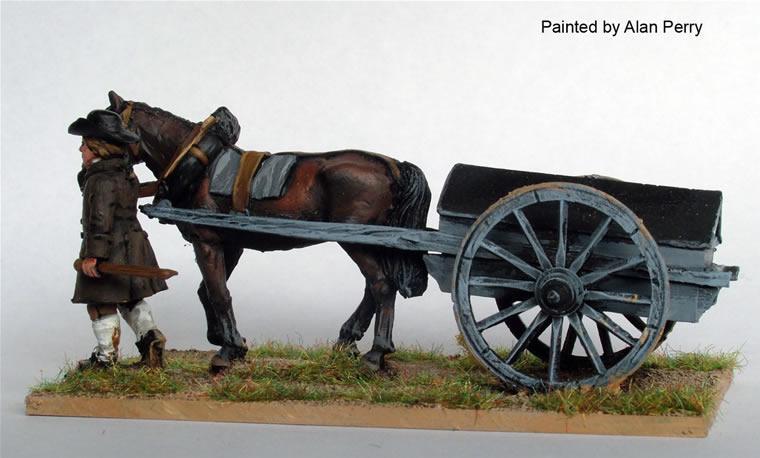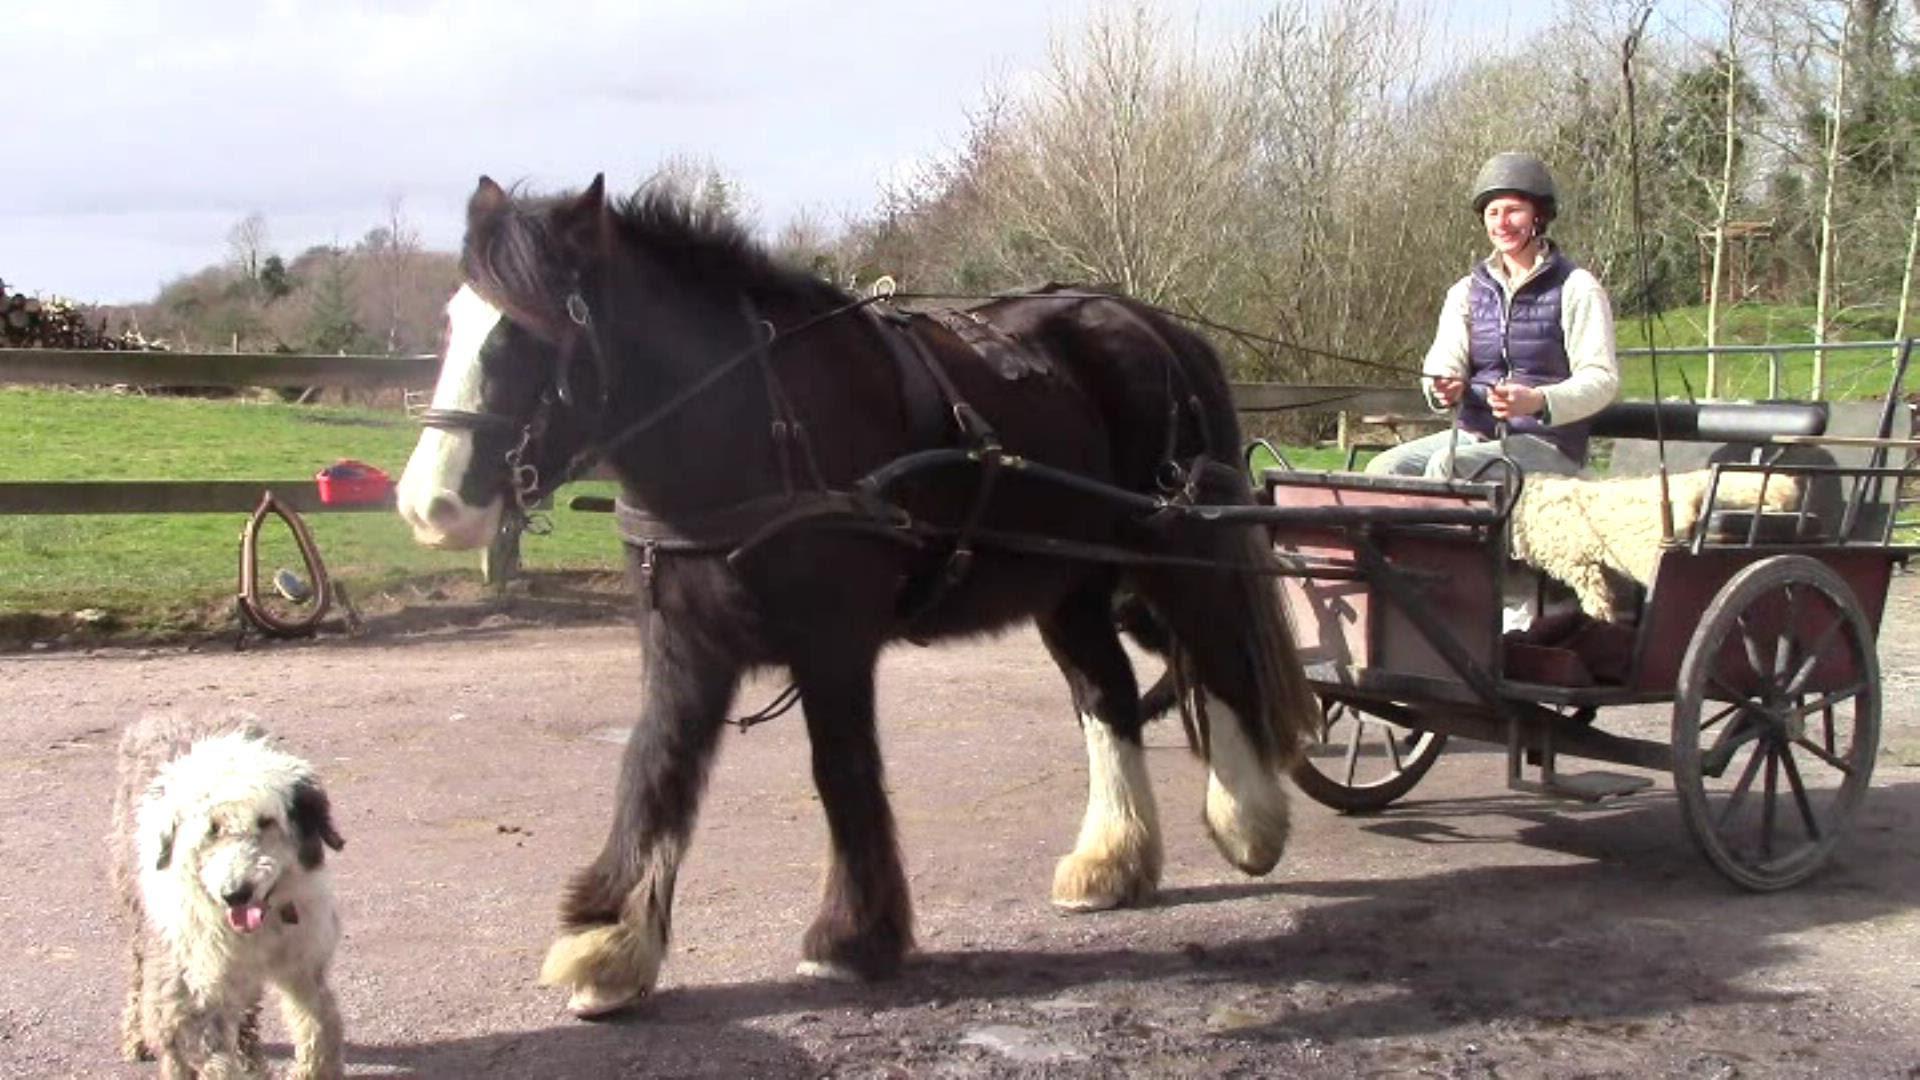The first image is the image on the left, the second image is the image on the right. For the images shown, is this caption "In one of the images the wagon is being pulled by two horses." true? Answer yes or no. No. 